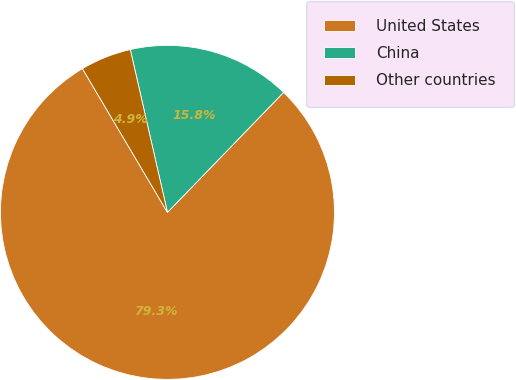<chart> <loc_0><loc_0><loc_500><loc_500><pie_chart><fcel>United States<fcel>China<fcel>Other countries<nl><fcel>79.26%<fcel>15.81%<fcel>4.93%<nl></chart> 